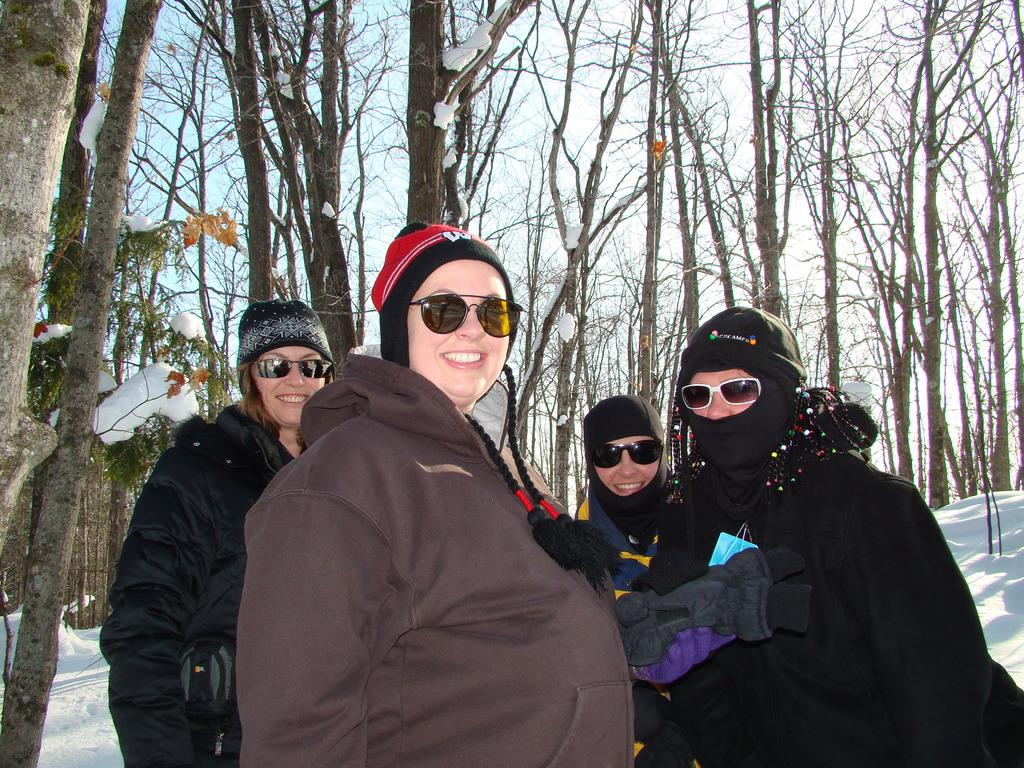How many women are in the foreground of the picture? There are four women in the foreground of the picture. What expressions do the women have? The women are smiling. What type of clothing are the women wearing? The women are wearing jackets and goggles. What can be seen in the background of the picture? There are trees and snow in the background of the picture. What type of silk fabric is draped over the jellyfish in the image? There are no jellyfish or silk fabric present in the image. Can you describe the smile of the jellyfish in the image? There are no jellyfish or smiles attributed to jellyfish in the image. 